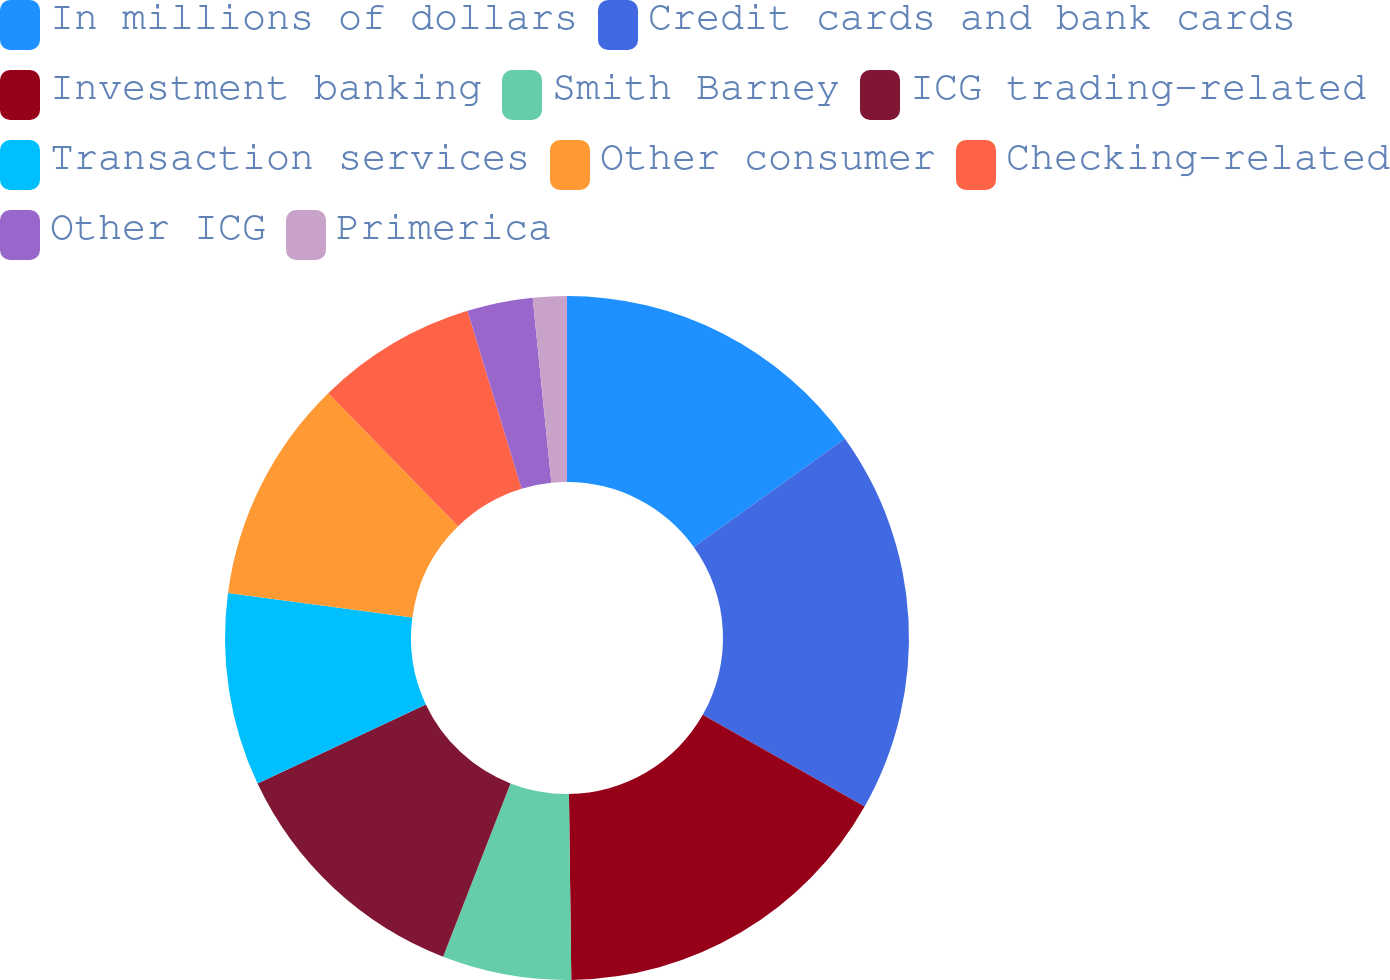<chart> <loc_0><loc_0><loc_500><loc_500><pie_chart><fcel>In millions of dollars<fcel>Credit cards and bank cards<fcel>Investment banking<fcel>Smith Barney<fcel>ICG trading-related<fcel>Transaction services<fcel>Other consumer<fcel>Checking-related<fcel>Other ICG<fcel>Primerica<nl><fcel>15.1%<fcel>18.1%<fcel>16.6%<fcel>6.1%<fcel>12.1%<fcel>9.1%<fcel>10.6%<fcel>7.6%<fcel>3.1%<fcel>1.6%<nl></chart> 